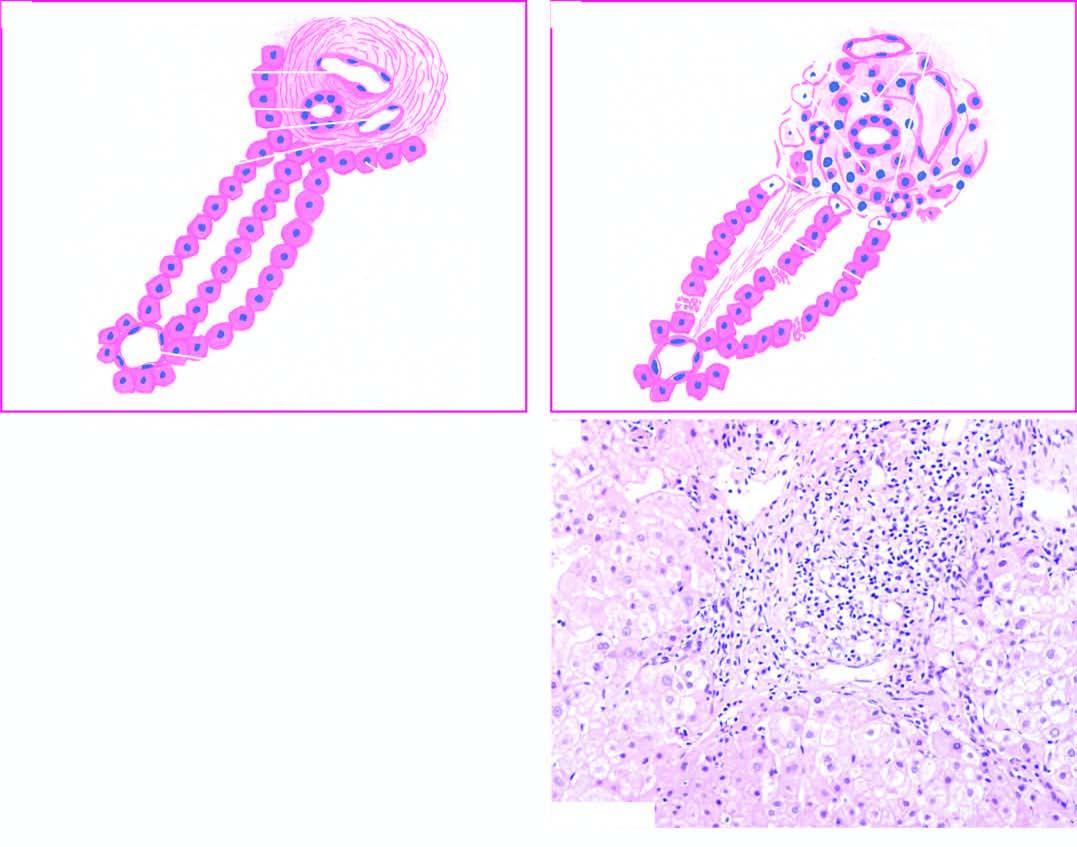what spurs into lobules?
Answer the question using a single word or phrase. Extension of fibrous 